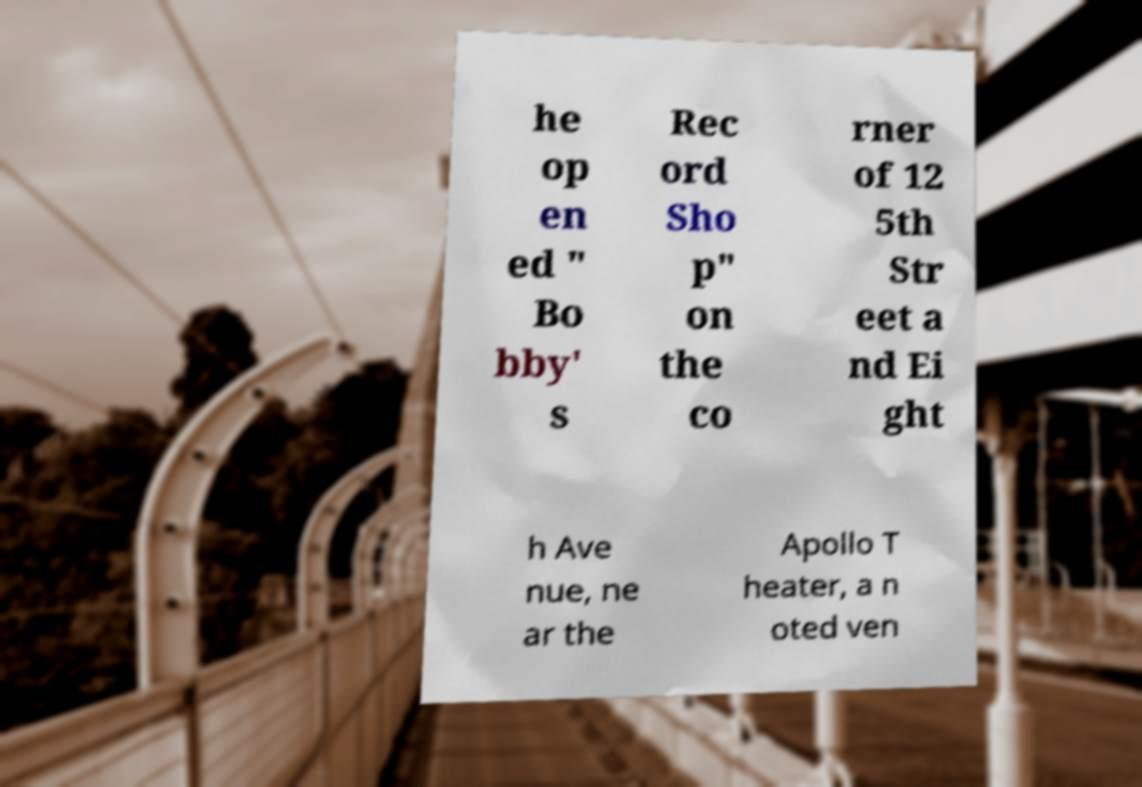Can you accurately transcribe the text from the provided image for me? he op en ed " Bo bby' s Rec ord Sho p" on the co rner of 12 5th Str eet a nd Ei ght h Ave nue, ne ar the Apollo T heater, a n oted ven 